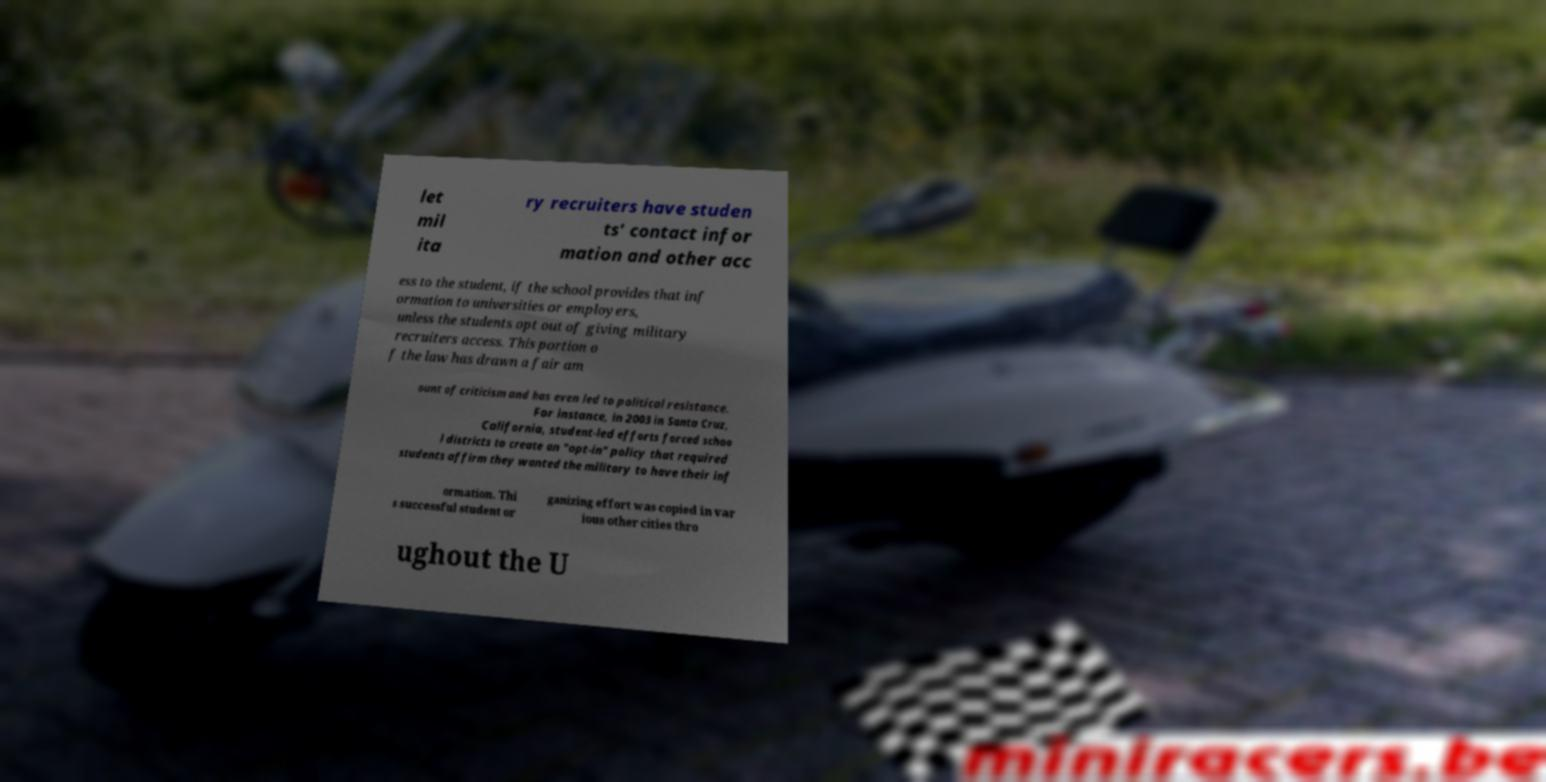Could you assist in decoding the text presented in this image and type it out clearly? let mil ita ry recruiters have studen ts' contact infor mation and other acc ess to the student, if the school provides that inf ormation to universities or employers, unless the students opt out of giving military recruiters access. This portion o f the law has drawn a fair am ount of criticism and has even led to political resistance. For instance, in 2003 in Santa Cruz, California, student-led efforts forced schoo l districts to create an "opt-in" policy that required students affirm they wanted the military to have their inf ormation. Thi s successful student or ganizing effort was copied in var ious other cities thro ughout the U 